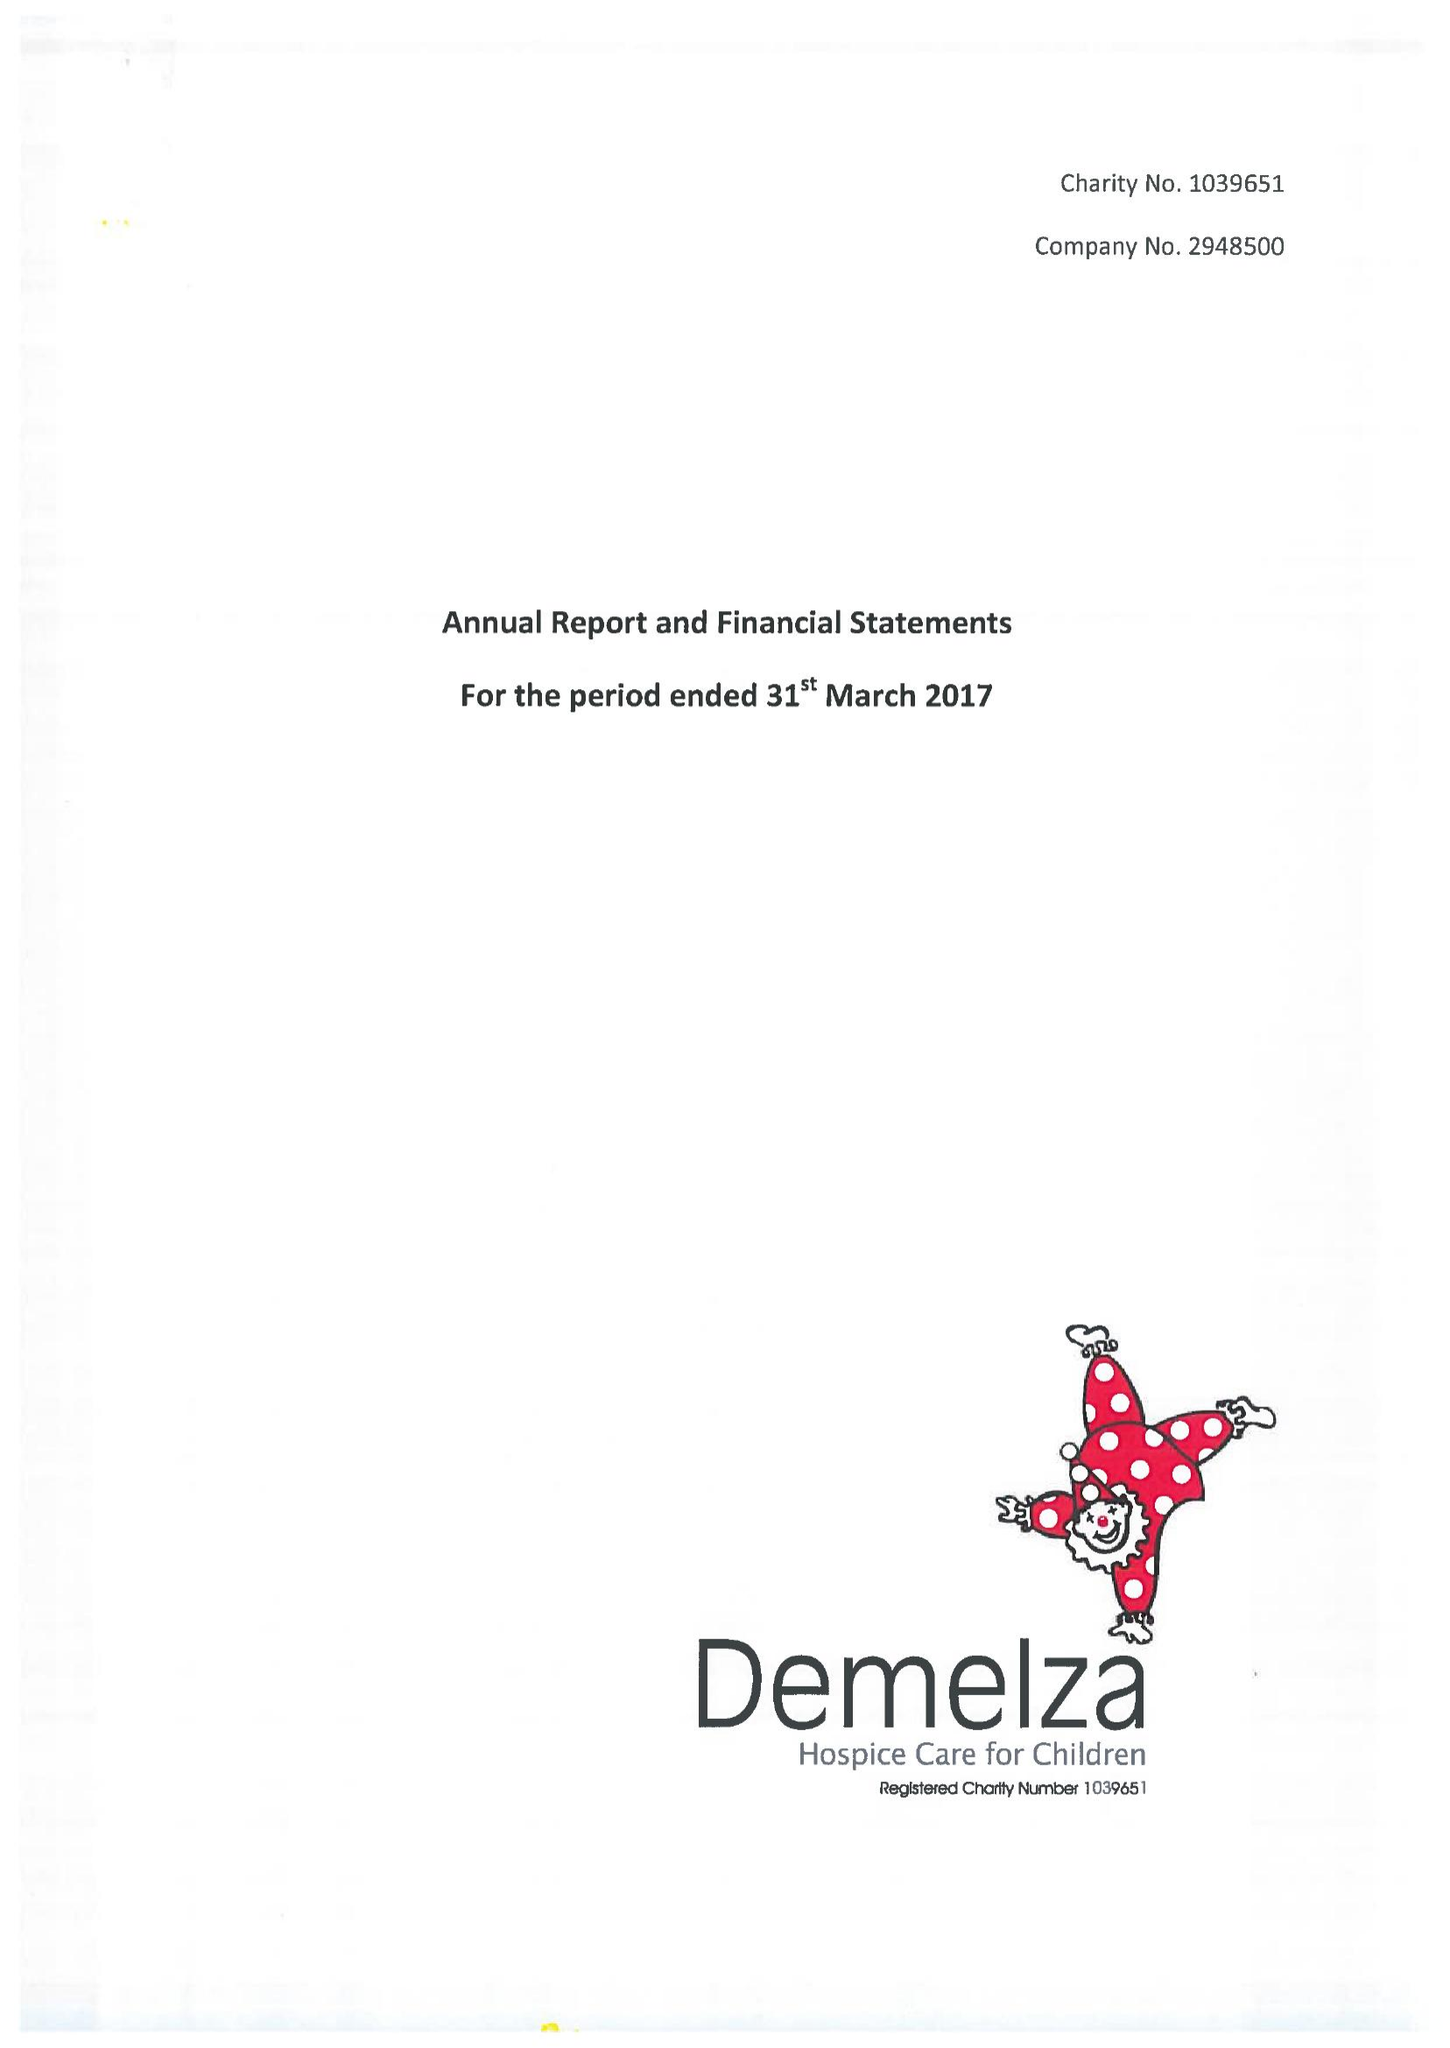What is the value for the spending_annually_in_british_pounds?
Answer the question using a single word or phrase. 14911903.00 